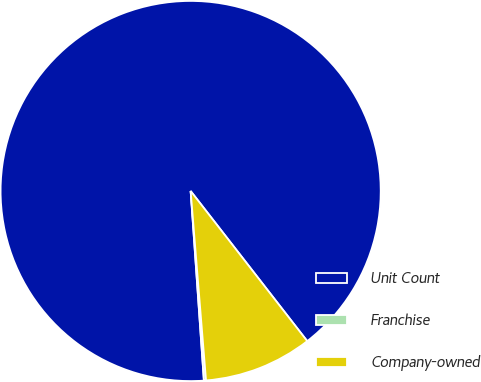Convert chart to OTSL. <chart><loc_0><loc_0><loc_500><loc_500><pie_chart><fcel>Unit Count<fcel>Franchise<fcel>Company-owned<nl><fcel>90.6%<fcel>0.18%<fcel>9.22%<nl></chart> 